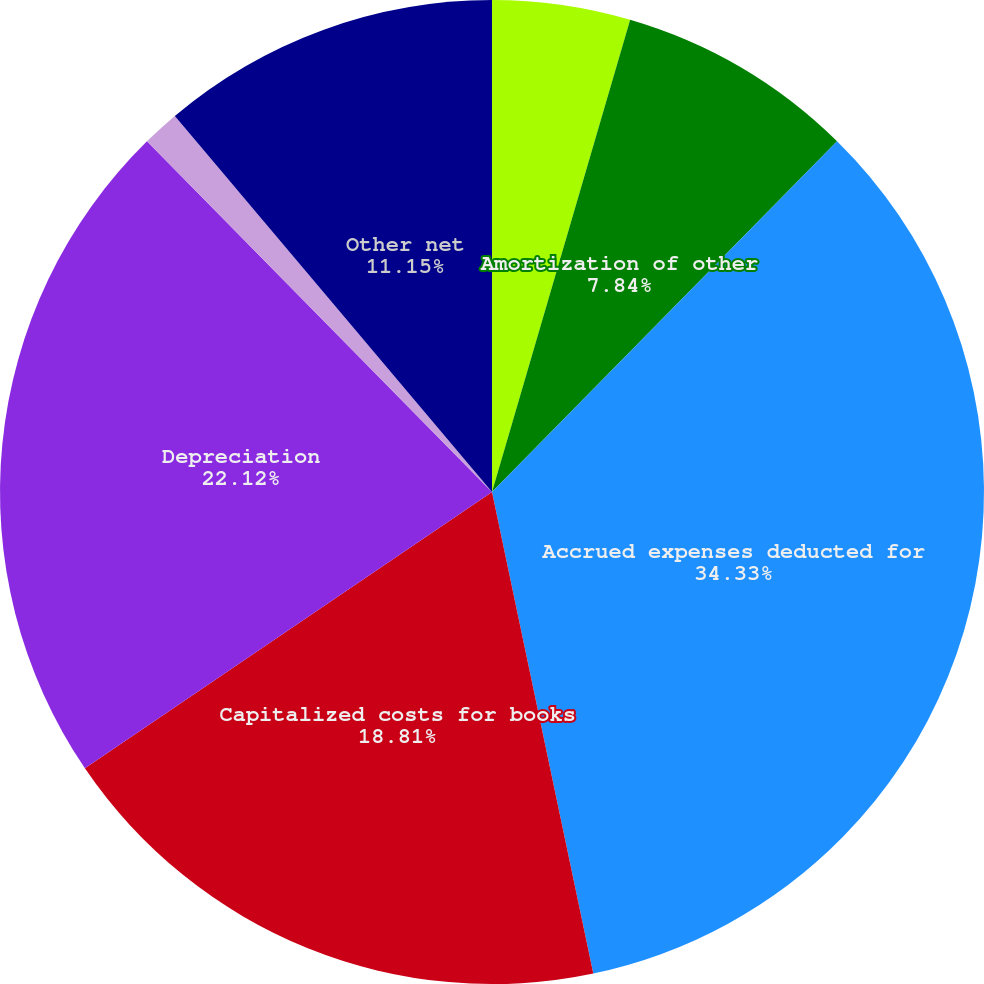Convert chart to OTSL. <chart><loc_0><loc_0><loc_500><loc_500><pie_chart><fcel>Amortization of franchise<fcel>Amortization of other<fcel>Accrued expenses deducted for<fcel>Capitalized costs for books<fcel>Depreciation<fcel>Federal impact of unrecognized<fcel>Other net<nl><fcel>4.53%<fcel>7.84%<fcel>34.33%<fcel>18.81%<fcel>22.12%<fcel>1.22%<fcel>11.15%<nl></chart> 